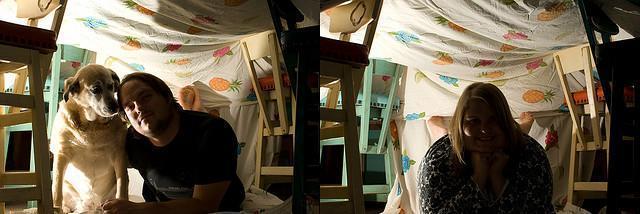How many people are there?
Give a very brief answer. 2. How many chairs are visible?
Give a very brief answer. 6. How many dogs are there?
Give a very brief answer. 1. 